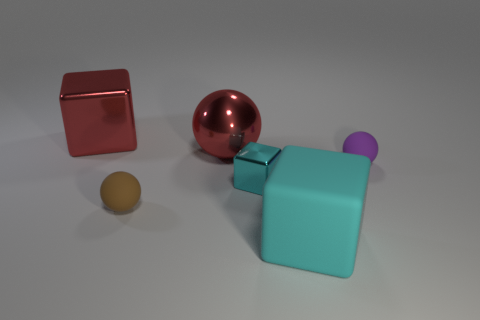Is there a big metallic object of the same color as the metallic ball?
Make the answer very short. Yes. There is a purple thing that is the same material as the small brown sphere; what is its size?
Keep it short and to the point. Small. Do the large red cube and the red ball have the same material?
Your answer should be compact. Yes. The metal block that is to the left of the red metal object to the right of the big cube that is behind the large cyan rubber thing is what color?
Your response must be concise. Red. The large rubber object has what shape?
Your answer should be compact. Cube. There is a big metallic ball; is its color the same as the large cube behind the brown object?
Give a very brief answer. Yes. Are there an equal number of small matte things that are to the left of the small brown matte thing and tiny metallic objects?
Your response must be concise. No. How many yellow metallic things have the same size as the brown object?
Your answer should be compact. 0. What shape is the thing that is the same color as the large sphere?
Your answer should be compact. Cube. Are any blue cubes visible?
Ensure brevity in your answer.  No. 